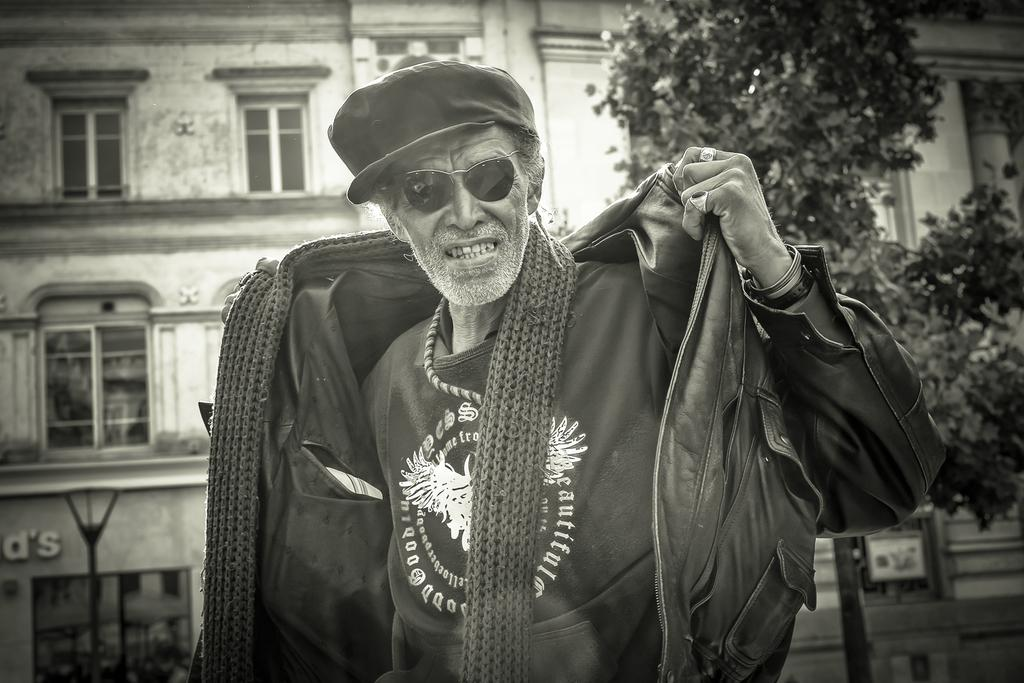What is the main subject of the image? There is a person in the image. What is the person wearing on their head? The person is wearing a cap. What type of eyewear is the person wearing? The person is wearing goggles. What is the person wearing as clothing? The person is wearing a dress. What can be seen in the background of the image? There are trees and a building with windows in the background of the image. What type of cave can be seen in the background of the image? There is no cave present in the image; only trees and a building with windows can be seen in the background. What type of rod is the person holding in the image? There is no rod present in the image; the person is wearing goggles, a cap, and a dress. 